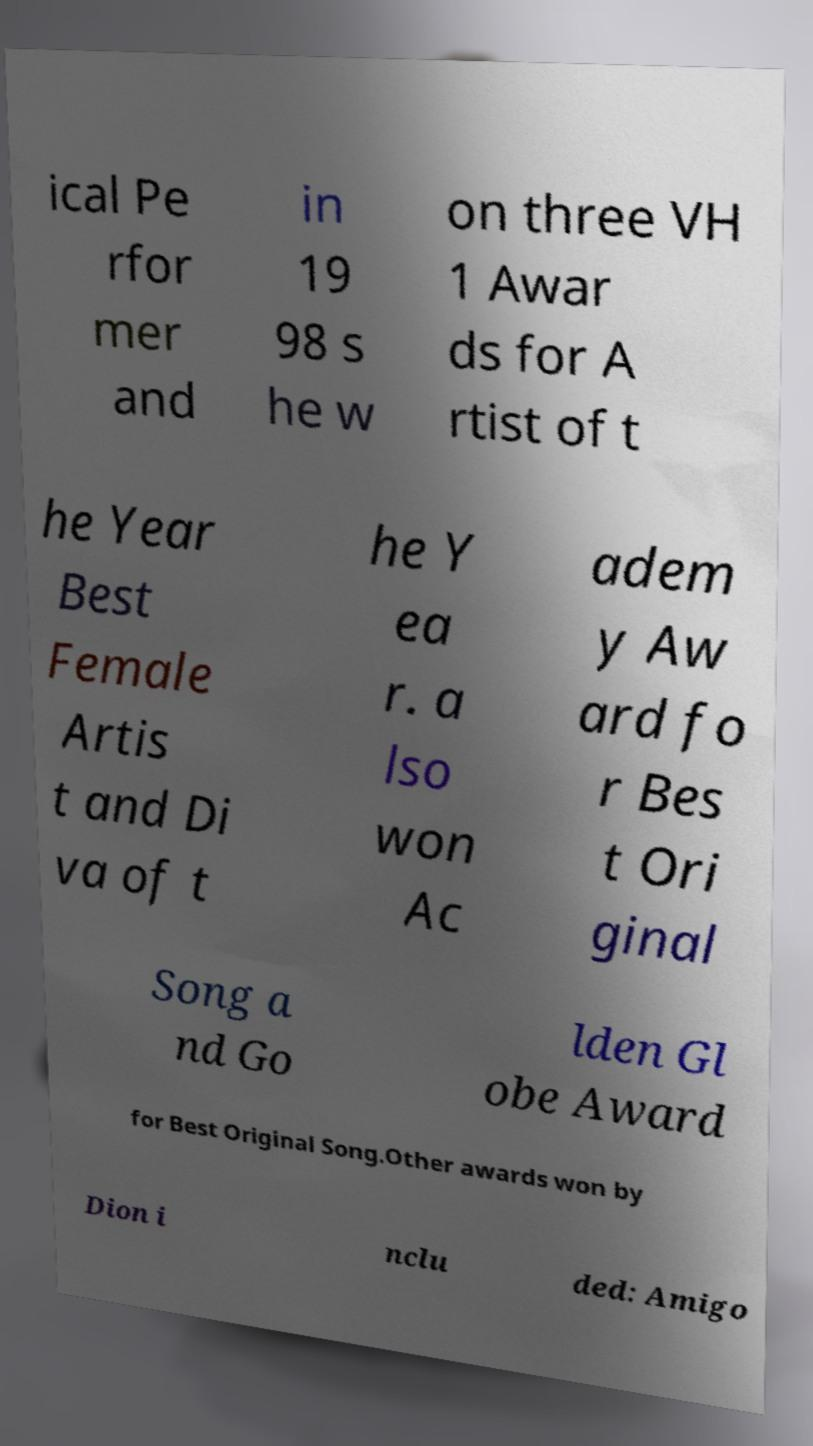Please identify and transcribe the text found in this image. ical Pe rfor mer and in 19 98 s he w on three VH 1 Awar ds for A rtist of t he Year Best Female Artis t and Di va of t he Y ea r. a lso won Ac adem y Aw ard fo r Bes t Ori ginal Song a nd Go lden Gl obe Award for Best Original Song.Other awards won by Dion i nclu ded: Amigo 